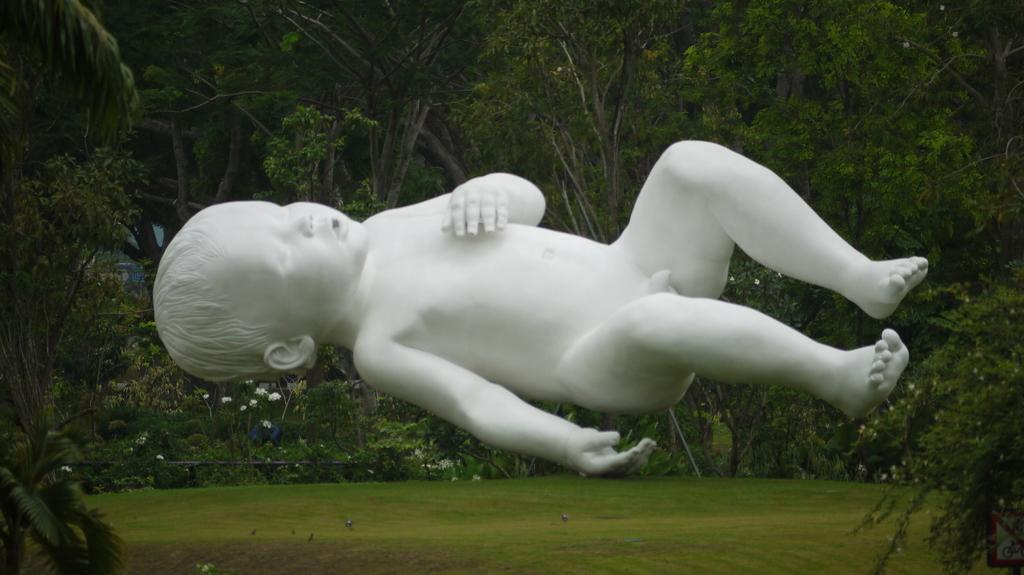What is the main subject of the image? There is a statue of a baby in the image. What can be seen in the background of the image? There are trees at the back of the image. Are there any plants visible in the image? Yes, there are flowers in the image. What is the surface material visible at the bottom of the image? There is grass at the bottom of the image. Is there any barrier or structure present in the image? Yes, there is a railing in the image. What type of paper is the baby holding in the image? There is no paper present in the image; the baby is a statue and cannot hold anything. 